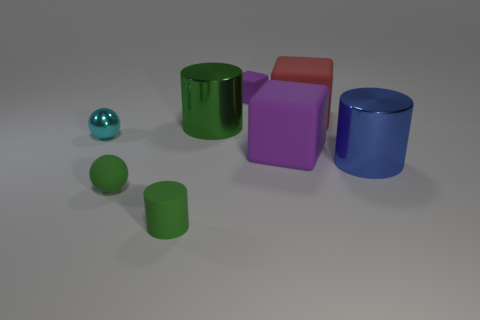Subtract all purple matte blocks. How many blocks are left? 1 Add 1 tiny rubber cylinders. How many objects exist? 9 Subtract all cyan balls. How many balls are left? 1 Subtract all cylinders. How many objects are left? 5 Subtract all blue blocks. How many green cylinders are left? 2 Subtract 0 cyan cylinders. How many objects are left? 8 Subtract 1 cubes. How many cubes are left? 2 Subtract all yellow balls. Subtract all gray blocks. How many balls are left? 2 Subtract all metal objects. Subtract all large yellow blocks. How many objects are left? 5 Add 4 green cylinders. How many green cylinders are left? 6 